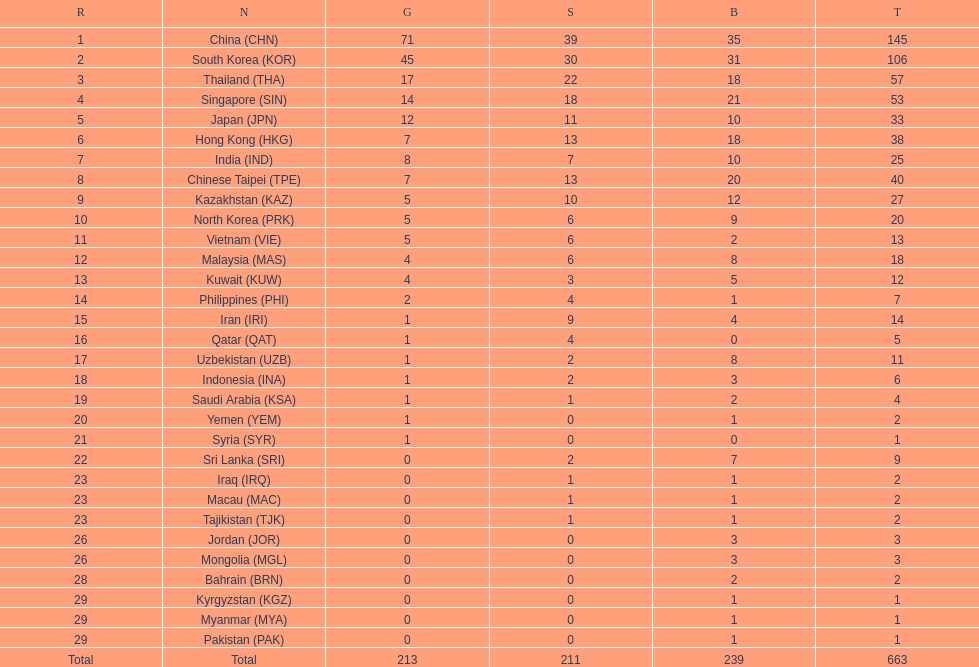How many countries have at least 10 gold medals in the asian youth games? 5. 